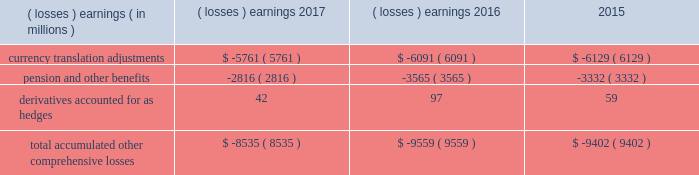Note 17 .
Accumulated other comprehensive losses : pmi's accumulated other comprehensive losses , net of taxes , consisted of the following: .
Reclassifications from other comprehensive earnings the movements in accumulated other comprehensive losses and the related tax impact , for each of the components above , that are due to current period activity and reclassifications to the income statement are shown on the consolidated statements of comprehensive earnings for the years ended december 31 , 2017 , 2016 , and 2015 .
For the years ended december 31 , 2017 , 2016 , and 2015 , $ 2 million , $ ( 5 ) million and $ 1 million of net currency translation adjustment gains/ ( losses ) were transferred from other comprehensive earnings to marketing , administration and research costs in the consolidated statements of earnings , respectively , upon liquidation of subsidiaries .
For additional information , see note 13 .
Benefit plans and note 15 .
Financial instruments for disclosures related to pmi's pension and other benefits and derivative financial instruments .
Note 18 .
Contingencies : tobacco-related litigation legal proceedings covering a wide range of matters are pending or threatened against us , and/or our subsidiaries , and/or our indemnitees in various jurisdictions .
Our indemnitees include distributors , licensees and others that have been named as parties in certain cases and that we have agreed to defend , as well as to pay costs and some or all of judgments , if any , that may be entered against them .
Pursuant to the terms of the distribution agreement between altria group , inc .
( "altria" ) and pmi , pmi will indemnify altria and philip morris usa inc .
( "pm usa" ) , a u.s .
Tobacco subsidiary of altria , for tobacco product claims based in substantial part on products manufactured by pmi or contract manufactured for pmi by pm usa , and pm usa will indemnify pmi for tobacco product claims based in substantial part on products manufactured by pm usa , excluding tobacco products contract manufactured for pmi .
It is possible that there could be adverse developments in pending cases against us and our subsidiaries .
An unfavorable outcome or settlement of pending tobacco-related litigation could encourage the commencement of additional litigation .
Damages claimed in some of the tobacco-related litigation are significant and , in certain cases in brazil , canada and nigeria , range into the billions of u.s .
Dollars .
The variability in pleadings in multiple jurisdictions , together with the actual experience of management in litigating claims , demonstrate that the monetary relief that may be specified in a lawsuit bears little relevance to the ultimate outcome .
Much of the tobacco-related litigation is in its early stages , and litigation is subject to uncertainty .
However , as discussed below , we have to date been largely successful in defending tobacco-related litigation .
We and our subsidiaries record provisions in the consolidated financial statements for pending litigation when we determine that an unfavorable outcome is probable and the amount of the loss can be reasonably estimated .
At the present time , while it is reasonably possible that an unfavorable outcome in a case may occur , after assessing the information available to it ( i ) management has not concluded that it is probable that a loss has been incurred in any of the pending tobacco-related cases ; ( ii ) management is unable to estimate the possible loss or range of loss for any of the pending tobacco-related cases ; and ( iii ) accordingly , no estimated loss has been accrued in the consolidated financial statements for unfavorable outcomes in these cases , if any .
Legal defense costs are expensed as incurred. .
What was the change in millions of total accumulated other comprehensive losses from 2016 to 2017? 
Computations: (-8535 - -9559)
Answer: 1024.0. 